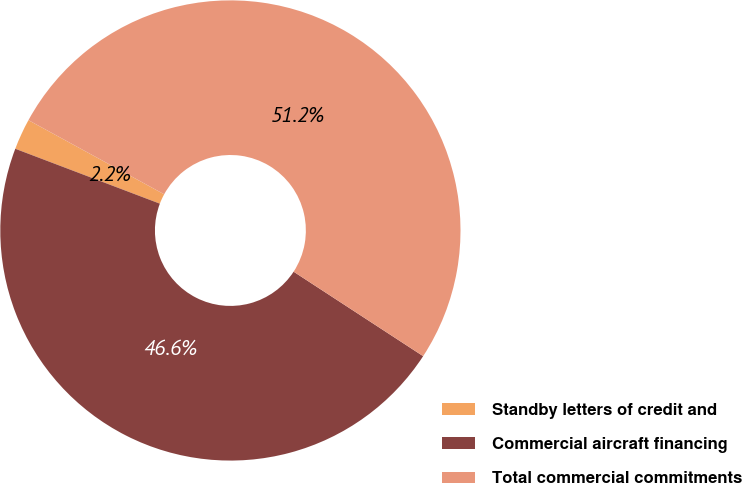<chart> <loc_0><loc_0><loc_500><loc_500><pie_chart><fcel>Standby letters of credit and<fcel>Commercial aircraft financing<fcel>Total commercial commitments<nl><fcel>2.18%<fcel>46.58%<fcel>51.24%<nl></chart> 